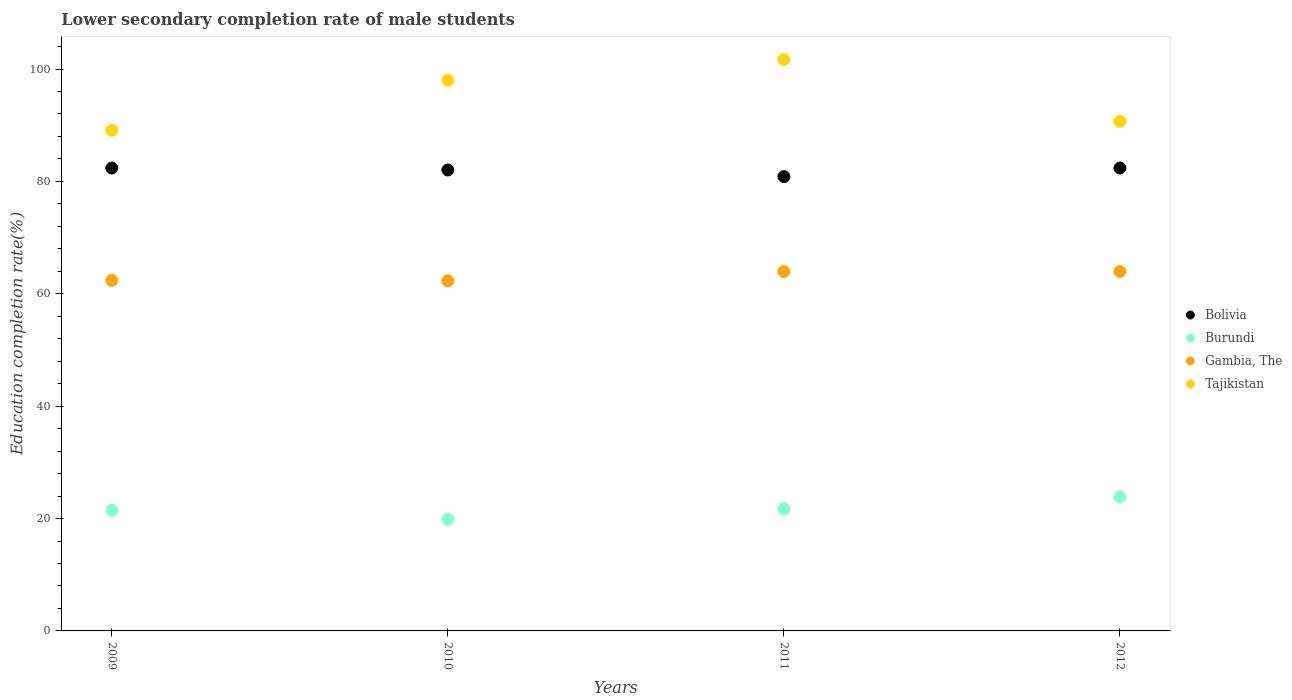What is the lower secondary completion rate of male students in Tajikistan in 2011?
Offer a terse response. 101.69. Across all years, what is the maximum lower secondary completion rate of male students in Bolivia?
Offer a terse response. 82.38. Across all years, what is the minimum lower secondary completion rate of male students in Bolivia?
Provide a short and direct response. 80.86. What is the total lower secondary completion rate of male students in Tajikistan in the graph?
Your answer should be very brief. 379.49. What is the difference between the lower secondary completion rate of male students in Burundi in 2009 and that in 2012?
Offer a terse response. -2.35. What is the difference between the lower secondary completion rate of male students in Bolivia in 2011 and the lower secondary completion rate of male students in Burundi in 2009?
Your answer should be compact. 59.38. What is the average lower secondary completion rate of male students in Gambia, The per year?
Make the answer very short. 63.15. In the year 2011, what is the difference between the lower secondary completion rate of male students in Gambia, The and lower secondary completion rate of male students in Burundi?
Keep it short and to the point. 42.22. What is the ratio of the lower secondary completion rate of male students in Burundi in 2010 to that in 2012?
Your answer should be compact. 0.83. What is the difference between the highest and the second highest lower secondary completion rate of male students in Tajikistan?
Offer a terse response. 3.68. What is the difference between the highest and the lowest lower secondary completion rate of male students in Gambia, The?
Offer a very short reply. 1.65. Is it the case that in every year, the sum of the lower secondary completion rate of male students in Gambia, The and lower secondary completion rate of male students in Bolivia  is greater than the sum of lower secondary completion rate of male students in Tajikistan and lower secondary completion rate of male students in Burundi?
Your answer should be compact. Yes. Is it the case that in every year, the sum of the lower secondary completion rate of male students in Burundi and lower secondary completion rate of male students in Gambia, The  is greater than the lower secondary completion rate of male students in Bolivia?
Your response must be concise. Yes. Does the lower secondary completion rate of male students in Gambia, The monotonically increase over the years?
Provide a short and direct response. No. How many years are there in the graph?
Ensure brevity in your answer.  4. What is the difference between two consecutive major ticks on the Y-axis?
Ensure brevity in your answer.  20. Does the graph contain any zero values?
Ensure brevity in your answer.  No. How many legend labels are there?
Your answer should be compact. 4. How are the legend labels stacked?
Ensure brevity in your answer.  Vertical. What is the title of the graph?
Make the answer very short. Lower secondary completion rate of male students. What is the label or title of the X-axis?
Ensure brevity in your answer.  Years. What is the label or title of the Y-axis?
Make the answer very short. Education completion rate(%). What is the Education completion rate(%) of Bolivia in 2009?
Your answer should be compact. 82.38. What is the Education completion rate(%) in Burundi in 2009?
Provide a succinct answer. 21.47. What is the Education completion rate(%) in Gambia, The in 2009?
Ensure brevity in your answer.  62.38. What is the Education completion rate(%) of Tajikistan in 2009?
Your response must be concise. 89.1. What is the Education completion rate(%) of Bolivia in 2010?
Give a very brief answer. 82.04. What is the Education completion rate(%) of Burundi in 2010?
Your answer should be compact. 19.88. What is the Education completion rate(%) in Gambia, The in 2010?
Provide a succinct answer. 62.31. What is the Education completion rate(%) in Tajikistan in 2010?
Offer a very short reply. 98.01. What is the Education completion rate(%) of Bolivia in 2011?
Ensure brevity in your answer.  80.86. What is the Education completion rate(%) in Burundi in 2011?
Offer a terse response. 21.73. What is the Education completion rate(%) in Gambia, The in 2011?
Keep it short and to the point. 63.95. What is the Education completion rate(%) in Tajikistan in 2011?
Offer a very short reply. 101.69. What is the Education completion rate(%) in Bolivia in 2012?
Ensure brevity in your answer.  82.38. What is the Education completion rate(%) of Burundi in 2012?
Keep it short and to the point. 23.83. What is the Education completion rate(%) of Gambia, The in 2012?
Offer a very short reply. 63.96. What is the Education completion rate(%) in Tajikistan in 2012?
Your response must be concise. 90.69. Across all years, what is the maximum Education completion rate(%) in Bolivia?
Keep it short and to the point. 82.38. Across all years, what is the maximum Education completion rate(%) of Burundi?
Offer a terse response. 23.83. Across all years, what is the maximum Education completion rate(%) of Gambia, The?
Offer a very short reply. 63.96. Across all years, what is the maximum Education completion rate(%) in Tajikistan?
Keep it short and to the point. 101.69. Across all years, what is the minimum Education completion rate(%) of Bolivia?
Your response must be concise. 80.86. Across all years, what is the minimum Education completion rate(%) of Burundi?
Your answer should be very brief. 19.88. Across all years, what is the minimum Education completion rate(%) in Gambia, The?
Provide a succinct answer. 62.31. Across all years, what is the minimum Education completion rate(%) in Tajikistan?
Offer a very short reply. 89.1. What is the total Education completion rate(%) in Bolivia in the graph?
Your answer should be compact. 327.66. What is the total Education completion rate(%) in Burundi in the graph?
Provide a short and direct response. 86.92. What is the total Education completion rate(%) of Gambia, The in the graph?
Keep it short and to the point. 252.6. What is the total Education completion rate(%) in Tajikistan in the graph?
Ensure brevity in your answer.  379.49. What is the difference between the Education completion rate(%) of Bolivia in 2009 and that in 2010?
Your answer should be very brief. 0.34. What is the difference between the Education completion rate(%) of Burundi in 2009 and that in 2010?
Keep it short and to the point. 1.59. What is the difference between the Education completion rate(%) of Gambia, The in 2009 and that in 2010?
Make the answer very short. 0.06. What is the difference between the Education completion rate(%) in Tajikistan in 2009 and that in 2010?
Provide a succinct answer. -8.91. What is the difference between the Education completion rate(%) of Bolivia in 2009 and that in 2011?
Your answer should be compact. 1.52. What is the difference between the Education completion rate(%) in Burundi in 2009 and that in 2011?
Provide a succinct answer. -0.26. What is the difference between the Education completion rate(%) in Gambia, The in 2009 and that in 2011?
Keep it short and to the point. -1.58. What is the difference between the Education completion rate(%) of Tajikistan in 2009 and that in 2011?
Ensure brevity in your answer.  -12.59. What is the difference between the Education completion rate(%) of Bolivia in 2009 and that in 2012?
Ensure brevity in your answer.  0. What is the difference between the Education completion rate(%) of Burundi in 2009 and that in 2012?
Ensure brevity in your answer.  -2.35. What is the difference between the Education completion rate(%) of Gambia, The in 2009 and that in 2012?
Ensure brevity in your answer.  -1.59. What is the difference between the Education completion rate(%) in Tajikistan in 2009 and that in 2012?
Ensure brevity in your answer.  -1.59. What is the difference between the Education completion rate(%) of Bolivia in 2010 and that in 2011?
Provide a short and direct response. 1.18. What is the difference between the Education completion rate(%) of Burundi in 2010 and that in 2011?
Keep it short and to the point. -1.85. What is the difference between the Education completion rate(%) in Gambia, The in 2010 and that in 2011?
Your response must be concise. -1.64. What is the difference between the Education completion rate(%) of Tajikistan in 2010 and that in 2011?
Make the answer very short. -3.68. What is the difference between the Education completion rate(%) in Bolivia in 2010 and that in 2012?
Offer a terse response. -0.34. What is the difference between the Education completion rate(%) in Burundi in 2010 and that in 2012?
Your answer should be compact. -3.94. What is the difference between the Education completion rate(%) of Gambia, The in 2010 and that in 2012?
Provide a short and direct response. -1.65. What is the difference between the Education completion rate(%) in Tajikistan in 2010 and that in 2012?
Your answer should be very brief. 7.32. What is the difference between the Education completion rate(%) of Bolivia in 2011 and that in 2012?
Offer a terse response. -1.52. What is the difference between the Education completion rate(%) of Burundi in 2011 and that in 2012?
Your answer should be compact. -2.09. What is the difference between the Education completion rate(%) in Gambia, The in 2011 and that in 2012?
Provide a succinct answer. -0.01. What is the difference between the Education completion rate(%) of Tajikistan in 2011 and that in 2012?
Provide a succinct answer. 11. What is the difference between the Education completion rate(%) of Bolivia in 2009 and the Education completion rate(%) of Burundi in 2010?
Offer a very short reply. 62.5. What is the difference between the Education completion rate(%) of Bolivia in 2009 and the Education completion rate(%) of Gambia, The in 2010?
Provide a short and direct response. 20.07. What is the difference between the Education completion rate(%) in Bolivia in 2009 and the Education completion rate(%) in Tajikistan in 2010?
Offer a very short reply. -15.63. What is the difference between the Education completion rate(%) of Burundi in 2009 and the Education completion rate(%) of Gambia, The in 2010?
Ensure brevity in your answer.  -40.84. What is the difference between the Education completion rate(%) in Burundi in 2009 and the Education completion rate(%) in Tajikistan in 2010?
Make the answer very short. -76.53. What is the difference between the Education completion rate(%) of Gambia, The in 2009 and the Education completion rate(%) of Tajikistan in 2010?
Your answer should be compact. -35.63. What is the difference between the Education completion rate(%) of Bolivia in 2009 and the Education completion rate(%) of Burundi in 2011?
Make the answer very short. 60.65. What is the difference between the Education completion rate(%) of Bolivia in 2009 and the Education completion rate(%) of Gambia, The in 2011?
Your answer should be very brief. 18.43. What is the difference between the Education completion rate(%) in Bolivia in 2009 and the Education completion rate(%) in Tajikistan in 2011?
Your answer should be compact. -19.31. What is the difference between the Education completion rate(%) of Burundi in 2009 and the Education completion rate(%) of Gambia, The in 2011?
Keep it short and to the point. -42.48. What is the difference between the Education completion rate(%) of Burundi in 2009 and the Education completion rate(%) of Tajikistan in 2011?
Offer a very short reply. -80.21. What is the difference between the Education completion rate(%) in Gambia, The in 2009 and the Education completion rate(%) in Tajikistan in 2011?
Your response must be concise. -39.31. What is the difference between the Education completion rate(%) in Bolivia in 2009 and the Education completion rate(%) in Burundi in 2012?
Provide a short and direct response. 58.56. What is the difference between the Education completion rate(%) in Bolivia in 2009 and the Education completion rate(%) in Gambia, The in 2012?
Provide a short and direct response. 18.42. What is the difference between the Education completion rate(%) of Bolivia in 2009 and the Education completion rate(%) of Tajikistan in 2012?
Give a very brief answer. -8.31. What is the difference between the Education completion rate(%) in Burundi in 2009 and the Education completion rate(%) in Gambia, The in 2012?
Provide a succinct answer. -42.49. What is the difference between the Education completion rate(%) in Burundi in 2009 and the Education completion rate(%) in Tajikistan in 2012?
Give a very brief answer. -69.22. What is the difference between the Education completion rate(%) in Gambia, The in 2009 and the Education completion rate(%) in Tajikistan in 2012?
Provide a short and direct response. -28.32. What is the difference between the Education completion rate(%) of Bolivia in 2010 and the Education completion rate(%) of Burundi in 2011?
Make the answer very short. 60.3. What is the difference between the Education completion rate(%) in Bolivia in 2010 and the Education completion rate(%) in Gambia, The in 2011?
Keep it short and to the point. 18.08. What is the difference between the Education completion rate(%) in Bolivia in 2010 and the Education completion rate(%) in Tajikistan in 2011?
Keep it short and to the point. -19.65. What is the difference between the Education completion rate(%) of Burundi in 2010 and the Education completion rate(%) of Gambia, The in 2011?
Offer a very short reply. -44.07. What is the difference between the Education completion rate(%) of Burundi in 2010 and the Education completion rate(%) of Tajikistan in 2011?
Ensure brevity in your answer.  -81.8. What is the difference between the Education completion rate(%) in Gambia, The in 2010 and the Education completion rate(%) in Tajikistan in 2011?
Keep it short and to the point. -39.38. What is the difference between the Education completion rate(%) in Bolivia in 2010 and the Education completion rate(%) in Burundi in 2012?
Your response must be concise. 58.21. What is the difference between the Education completion rate(%) in Bolivia in 2010 and the Education completion rate(%) in Gambia, The in 2012?
Keep it short and to the point. 18.08. What is the difference between the Education completion rate(%) in Bolivia in 2010 and the Education completion rate(%) in Tajikistan in 2012?
Give a very brief answer. -8.65. What is the difference between the Education completion rate(%) in Burundi in 2010 and the Education completion rate(%) in Gambia, The in 2012?
Offer a very short reply. -44.08. What is the difference between the Education completion rate(%) of Burundi in 2010 and the Education completion rate(%) of Tajikistan in 2012?
Give a very brief answer. -70.81. What is the difference between the Education completion rate(%) of Gambia, The in 2010 and the Education completion rate(%) of Tajikistan in 2012?
Your response must be concise. -28.38. What is the difference between the Education completion rate(%) of Bolivia in 2011 and the Education completion rate(%) of Burundi in 2012?
Make the answer very short. 57.03. What is the difference between the Education completion rate(%) in Bolivia in 2011 and the Education completion rate(%) in Gambia, The in 2012?
Offer a terse response. 16.9. What is the difference between the Education completion rate(%) in Bolivia in 2011 and the Education completion rate(%) in Tajikistan in 2012?
Your response must be concise. -9.83. What is the difference between the Education completion rate(%) of Burundi in 2011 and the Education completion rate(%) of Gambia, The in 2012?
Provide a short and direct response. -42.23. What is the difference between the Education completion rate(%) of Burundi in 2011 and the Education completion rate(%) of Tajikistan in 2012?
Make the answer very short. -68.96. What is the difference between the Education completion rate(%) in Gambia, The in 2011 and the Education completion rate(%) in Tajikistan in 2012?
Your answer should be compact. -26.74. What is the average Education completion rate(%) in Bolivia per year?
Your answer should be very brief. 81.91. What is the average Education completion rate(%) of Burundi per year?
Keep it short and to the point. 21.73. What is the average Education completion rate(%) in Gambia, The per year?
Provide a short and direct response. 63.15. What is the average Education completion rate(%) of Tajikistan per year?
Your response must be concise. 94.87. In the year 2009, what is the difference between the Education completion rate(%) in Bolivia and Education completion rate(%) in Burundi?
Your response must be concise. 60.91. In the year 2009, what is the difference between the Education completion rate(%) in Bolivia and Education completion rate(%) in Gambia, The?
Offer a terse response. 20.01. In the year 2009, what is the difference between the Education completion rate(%) in Bolivia and Education completion rate(%) in Tajikistan?
Offer a terse response. -6.72. In the year 2009, what is the difference between the Education completion rate(%) of Burundi and Education completion rate(%) of Gambia, The?
Offer a very short reply. -40.9. In the year 2009, what is the difference between the Education completion rate(%) in Burundi and Education completion rate(%) in Tajikistan?
Your response must be concise. -67.62. In the year 2009, what is the difference between the Education completion rate(%) of Gambia, The and Education completion rate(%) of Tajikistan?
Keep it short and to the point. -26.72. In the year 2010, what is the difference between the Education completion rate(%) in Bolivia and Education completion rate(%) in Burundi?
Ensure brevity in your answer.  62.15. In the year 2010, what is the difference between the Education completion rate(%) of Bolivia and Education completion rate(%) of Gambia, The?
Make the answer very short. 19.73. In the year 2010, what is the difference between the Education completion rate(%) in Bolivia and Education completion rate(%) in Tajikistan?
Your answer should be compact. -15.97. In the year 2010, what is the difference between the Education completion rate(%) of Burundi and Education completion rate(%) of Gambia, The?
Your response must be concise. -42.43. In the year 2010, what is the difference between the Education completion rate(%) in Burundi and Education completion rate(%) in Tajikistan?
Your response must be concise. -78.12. In the year 2010, what is the difference between the Education completion rate(%) of Gambia, The and Education completion rate(%) of Tajikistan?
Make the answer very short. -35.7. In the year 2011, what is the difference between the Education completion rate(%) of Bolivia and Education completion rate(%) of Burundi?
Keep it short and to the point. 59.12. In the year 2011, what is the difference between the Education completion rate(%) in Bolivia and Education completion rate(%) in Gambia, The?
Offer a terse response. 16.9. In the year 2011, what is the difference between the Education completion rate(%) of Bolivia and Education completion rate(%) of Tajikistan?
Your response must be concise. -20.83. In the year 2011, what is the difference between the Education completion rate(%) of Burundi and Education completion rate(%) of Gambia, The?
Offer a terse response. -42.22. In the year 2011, what is the difference between the Education completion rate(%) in Burundi and Education completion rate(%) in Tajikistan?
Ensure brevity in your answer.  -79.95. In the year 2011, what is the difference between the Education completion rate(%) of Gambia, The and Education completion rate(%) of Tajikistan?
Your answer should be very brief. -37.73. In the year 2012, what is the difference between the Education completion rate(%) in Bolivia and Education completion rate(%) in Burundi?
Provide a short and direct response. 58.56. In the year 2012, what is the difference between the Education completion rate(%) of Bolivia and Education completion rate(%) of Gambia, The?
Your answer should be very brief. 18.42. In the year 2012, what is the difference between the Education completion rate(%) in Bolivia and Education completion rate(%) in Tajikistan?
Offer a very short reply. -8.31. In the year 2012, what is the difference between the Education completion rate(%) in Burundi and Education completion rate(%) in Gambia, The?
Your answer should be compact. -40.14. In the year 2012, what is the difference between the Education completion rate(%) of Burundi and Education completion rate(%) of Tajikistan?
Keep it short and to the point. -66.87. In the year 2012, what is the difference between the Education completion rate(%) in Gambia, The and Education completion rate(%) in Tajikistan?
Your answer should be compact. -26.73. What is the ratio of the Education completion rate(%) of Burundi in 2009 to that in 2010?
Your answer should be compact. 1.08. What is the ratio of the Education completion rate(%) in Tajikistan in 2009 to that in 2010?
Make the answer very short. 0.91. What is the ratio of the Education completion rate(%) of Bolivia in 2009 to that in 2011?
Give a very brief answer. 1.02. What is the ratio of the Education completion rate(%) in Gambia, The in 2009 to that in 2011?
Give a very brief answer. 0.98. What is the ratio of the Education completion rate(%) of Tajikistan in 2009 to that in 2011?
Offer a terse response. 0.88. What is the ratio of the Education completion rate(%) in Burundi in 2009 to that in 2012?
Provide a short and direct response. 0.9. What is the ratio of the Education completion rate(%) in Gambia, The in 2009 to that in 2012?
Offer a terse response. 0.98. What is the ratio of the Education completion rate(%) of Tajikistan in 2009 to that in 2012?
Keep it short and to the point. 0.98. What is the ratio of the Education completion rate(%) in Bolivia in 2010 to that in 2011?
Offer a very short reply. 1.01. What is the ratio of the Education completion rate(%) of Burundi in 2010 to that in 2011?
Offer a very short reply. 0.91. What is the ratio of the Education completion rate(%) in Gambia, The in 2010 to that in 2011?
Give a very brief answer. 0.97. What is the ratio of the Education completion rate(%) of Tajikistan in 2010 to that in 2011?
Your answer should be compact. 0.96. What is the ratio of the Education completion rate(%) of Burundi in 2010 to that in 2012?
Your answer should be compact. 0.83. What is the ratio of the Education completion rate(%) of Gambia, The in 2010 to that in 2012?
Keep it short and to the point. 0.97. What is the ratio of the Education completion rate(%) in Tajikistan in 2010 to that in 2012?
Your response must be concise. 1.08. What is the ratio of the Education completion rate(%) in Bolivia in 2011 to that in 2012?
Your response must be concise. 0.98. What is the ratio of the Education completion rate(%) of Burundi in 2011 to that in 2012?
Ensure brevity in your answer.  0.91. What is the ratio of the Education completion rate(%) of Tajikistan in 2011 to that in 2012?
Ensure brevity in your answer.  1.12. What is the difference between the highest and the second highest Education completion rate(%) in Bolivia?
Your answer should be compact. 0. What is the difference between the highest and the second highest Education completion rate(%) in Burundi?
Keep it short and to the point. 2.09. What is the difference between the highest and the second highest Education completion rate(%) of Gambia, The?
Your answer should be very brief. 0.01. What is the difference between the highest and the second highest Education completion rate(%) of Tajikistan?
Your answer should be very brief. 3.68. What is the difference between the highest and the lowest Education completion rate(%) of Bolivia?
Your response must be concise. 1.52. What is the difference between the highest and the lowest Education completion rate(%) in Burundi?
Offer a very short reply. 3.94. What is the difference between the highest and the lowest Education completion rate(%) in Gambia, The?
Your answer should be compact. 1.65. What is the difference between the highest and the lowest Education completion rate(%) of Tajikistan?
Offer a very short reply. 12.59. 